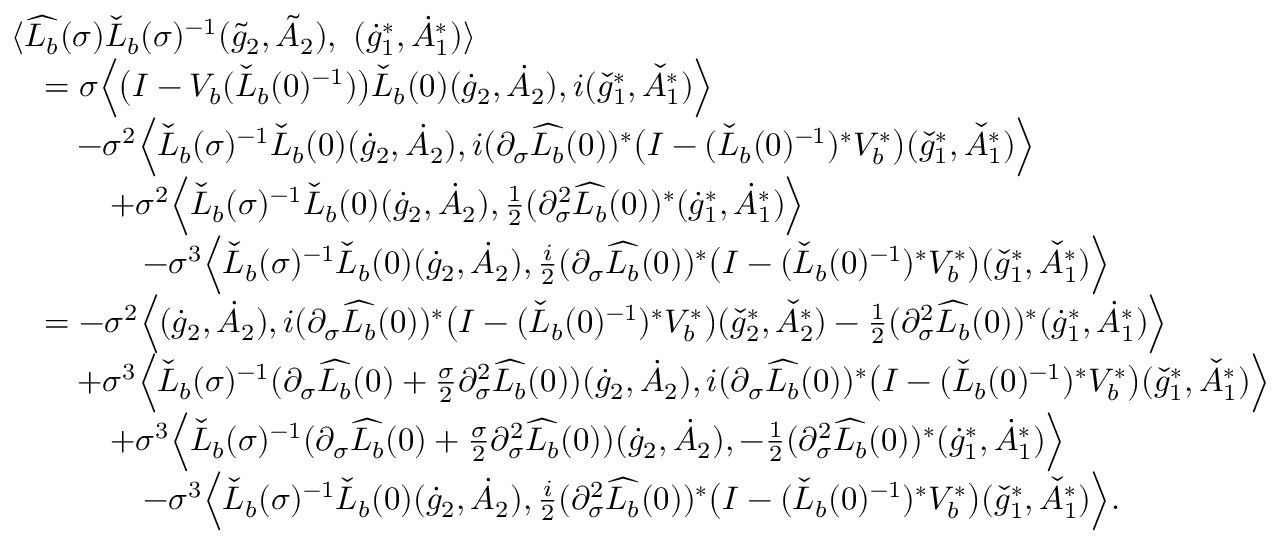Convert formula to latex. <formula><loc_0><loc_0><loc_500><loc_500>\begin{array} { r l } & { \langle \widehat { L _ { b } } ( \sigma ) \check { L } _ { b } ( \sigma ) ^ { - 1 } ( \tilde { g } _ { 2 } , \tilde { A } _ { 2 } ) , \ ( \dot { g } _ { 1 } ^ { * } , \dot { A } _ { 1 } ^ { * } ) \rangle } \\ & { \quad = \sigma \left \langle \left ( I - V _ { b } ( \check { L } _ { b } ( 0 ) ^ { - 1 } ) \right ) \check { L } _ { b } ( 0 ) ( \dot { g } _ { 2 } , \dot { A } _ { 2 } ) , i ( \check { g } _ { 1 } ^ { * } , \check { A } _ { 1 } ^ { * } ) \right \rangle } \\ & { \quad - \sigma ^ { 2 } \left \langle \check { L } _ { b } ( \sigma ) ^ { - 1 } \check { L } _ { b } ( 0 ) ( \dot { g } _ { 2 } , \dot { A } _ { 2 } ) , i ( \partial _ { \sigma } \widehat { L _ { b } } ( 0 ) ) ^ { * } \left ( I - ( \check { L } _ { b } ( 0 ) ^ { - 1 } ) ^ { * } V _ { b } ^ { * } \right ) ( \check { g } _ { 1 } ^ { * } , \check { A } _ { 1 } ^ { * } ) \right \rangle } \\ & { \quad + \sigma ^ { 2 } \left \langle \check { L } _ { b } ( \sigma ) ^ { - 1 } \check { L } _ { b } ( 0 ) ( \dot { g } _ { 2 } , \dot { A } _ { 2 } ) , \frac { 1 } { 2 } ( \partial _ { \sigma } ^ { 2 } \widehat { L _ { b } } ( 0 ) ) ^ { * } ( \dot { g } _ { 1 } ^ { * } , \dot { A } _ { 1 } ^ { * } ) \right \rangle } \\ & { \quad - \sigma ^ { 3 } \left \langle \check { L } _ { b } ( \sigma ) ^ { - 1 } \check { L } _ { b } ( 0 ) ( \dot { g } _ { 2 } , \dot { A } _ { 2 } ) , \frac { i } { 2 } ( \partial _ { \sigma } \widehat { L _ { b } } ( 0 ) ) ^ { * } \left ( I - ( \check { L } _ { b } ( 0 ) ^ { - 1 } ) ^ { * } V _ { b } ^ { * } \right ) ( \check { g } _ { 1 } ^ { * } , \check { A } _ { 1 } ^ { * } ) \right \rangle } \\ & { \quad = - \sigma ^ { 2 } \left \langle ( \dot { g } _ { 2 } , \dot { A } _ { 2 } ) , i ( \partial _ { \sigma } \widehat { L _ { b } } ( 0 ) ) ^ { * } \left ( I - ( \check { L } _ { b } ( 0 ) ^ { - 1 } ) ^ { * } V _ { b } ^ { * } \right ) ( \check { g } _ { 2 } ^ { * } , \check { A } _ { 2 } ^ { * } ) - \frac { 1 } { 2 } ( \partial _ { \sigma } ^ { 2 } \widehat { L _ { b } } ( 0 ) ) ^ { * } ( \dot { g } _ { 1 } ^ { * } , \dot { A } _ { 1 } ^ { * } ) \right \rangle } \\ & { \quad + \sigma ^ { 3 } \left \langle \check { L } _ { b } ( \sigma ) ^ { - 1 } ( \partial _ { \sigma } \widehat { L _ { b } } ( 0 ) + \frac { \sigma } { 2 } \partial _ { \sigma } ^ { 2 } \widehat { L _ { b } } ( 0 ) ) ( \dot { g } _ { 2 } , \dot { A } _ { 2 } ) , i ( \partial _ { \sigma } \widehat { L _ { b } } ( 0 ) ) ^ { * } \left ( I - ( \check { L } _ { b } ( 0 ) ^ { - 1 } ) ^ { * } V _ { b } ^ { * } \right ) ( \check { g } _ { 1 } ^ { * } , \check { A } _ { 1 } ^ { * } ) \right \rangle } \\ & { \quad + \sigma ^ { 3 } \left \langle \check { L } _ { b } ( \sigma ) ^ { - 1 } ( \partial _ { \sigma } \widehat { L _ { b } } ( 0 ) + \frac { \sigma } { 2 } \partial _ { \sigma } ^ { 2 } \widehat { L _ { b } } ( 0 ) ) ( \dot { g } _ { 2 } , \dot { A } _ { 2 } ) , - \frac { 1 } { 2 } ( \partial _ { \sigma } ^ { 2 } \widehat { L _ { b } } ( 0 ) ) ^ { * } ( \dot { g } _ { 1 } ^ { * } , \dot { A } _ { 1 } ^ { * } ) \right \rangle } \\ & { \quad - \sigma ^ { 3 } \left \langle \check { L } _ { b } ( \sigma ) ^ { - 1 } \check { L } _ { b } ( 0 ) ( \dot { g } _ { 2 } , \dot { A } _ { 2 } ) , \frac { i } { 2 } ( \partial _ { \sigma } ^ { 2 } \widehat { L _ { b } } ( 0 ) ) ^ { * } \left ( I - ( \check { L } _ { b } ( 0 ) ^ { - 1 } ) ^ { * } V _ { b } ^ { * } \right ) ( \check { g } _ { 1 } ^ { * } , \check { A } _ { 1 } ^ { * } ) \right \rangle . } \end{array}</formula> 